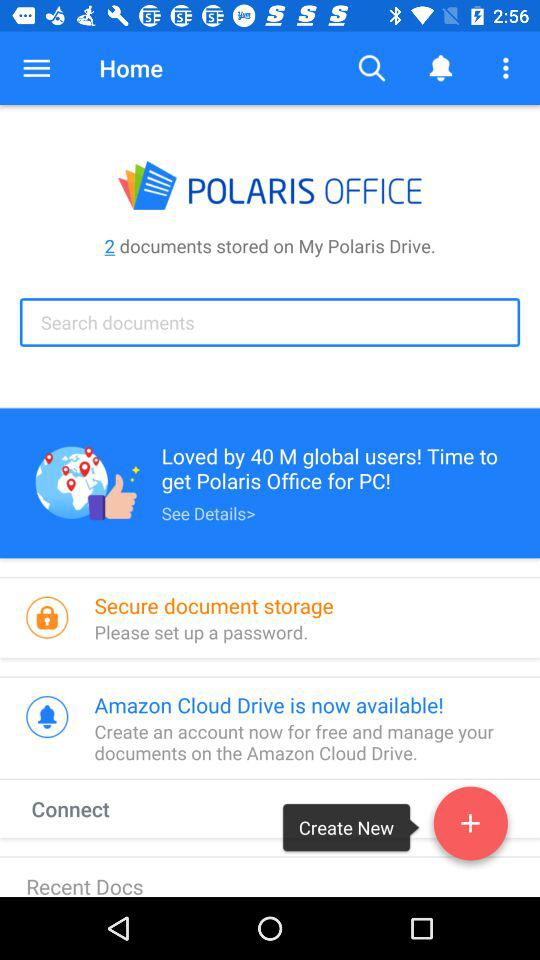How many documents are stored on My Polaris Drive?
Answer the question using a single word or phrase. 2 